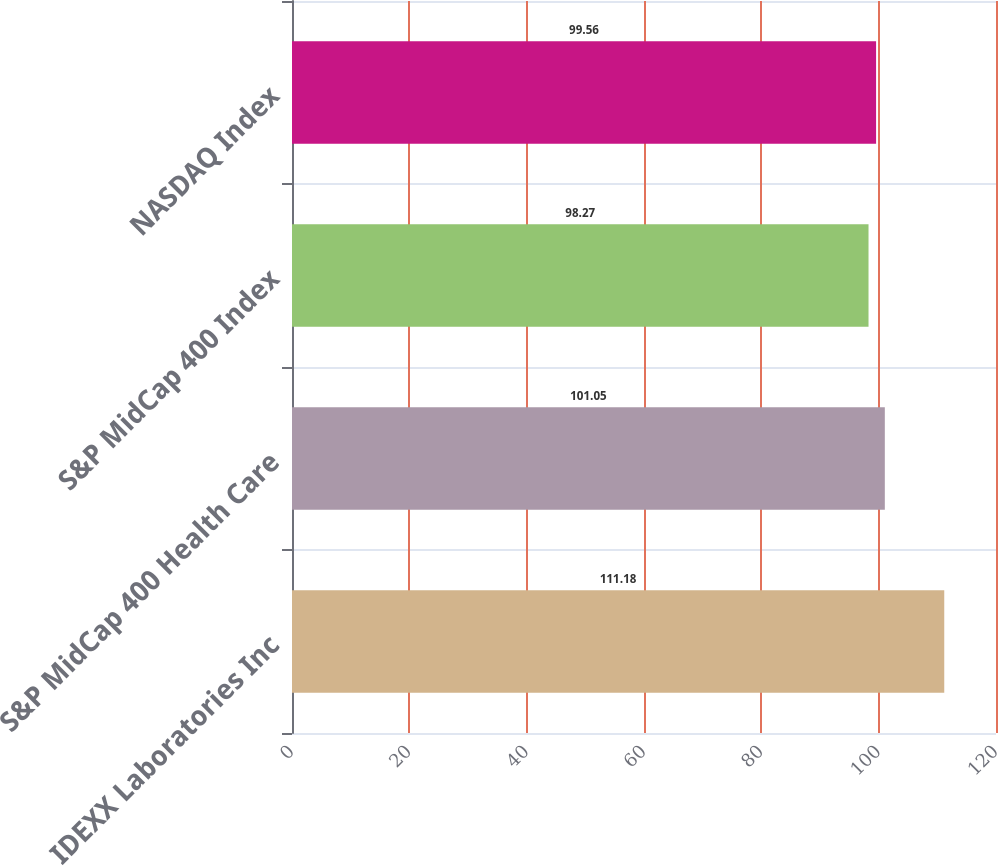<chart> <loc_0><loc_0><loc_500><loc_500><bar_chart><fcel>IDEXX Laboratories Inc<fcel>S&P MidCap 400 Health Care<fcel>S&P MidCap 400 Index<fcel>NASDAQ Index<nl><fcel>111.18<fcel>101.05<fcel>98.27<fcel>99.56<nl></chart> 